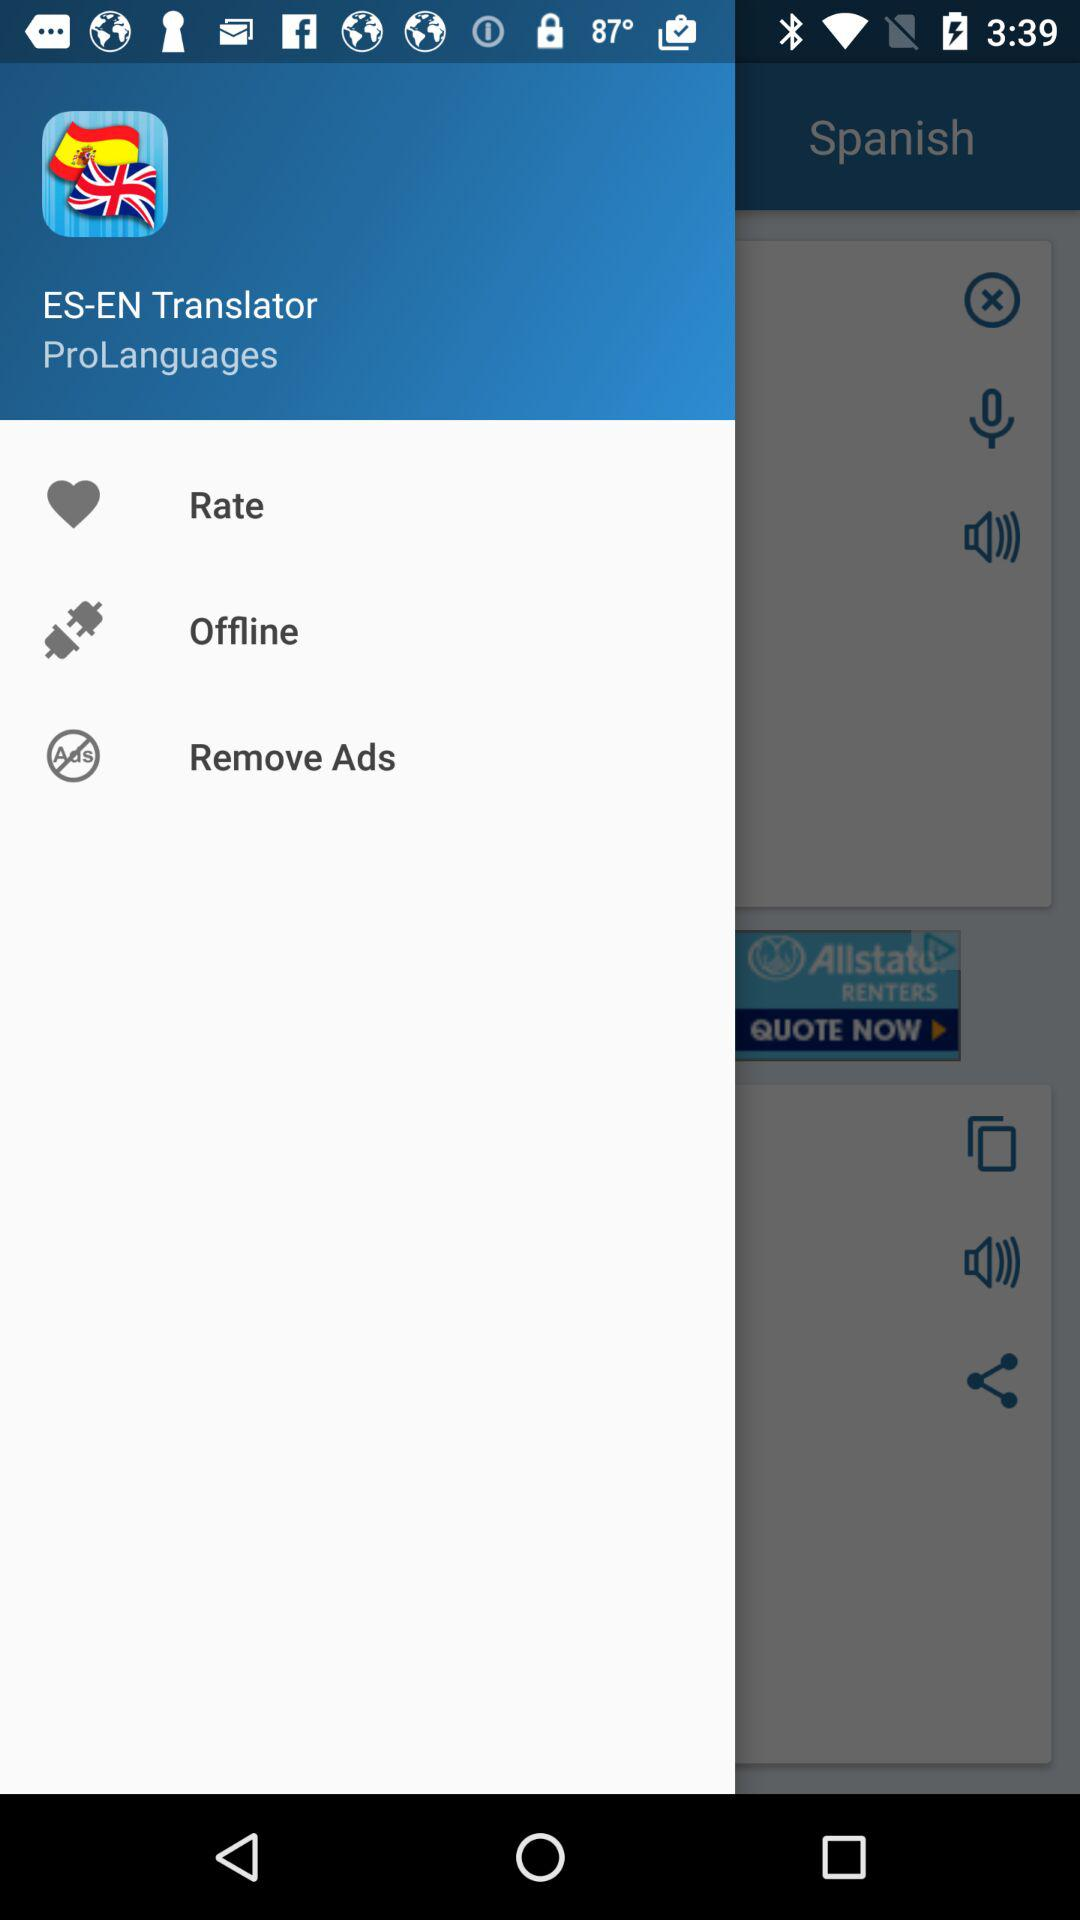What is the application name? The application name is "ES-EN Translator". 